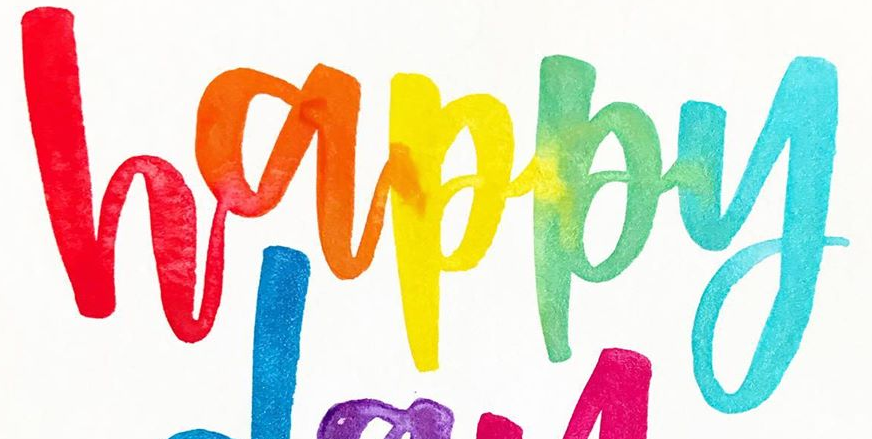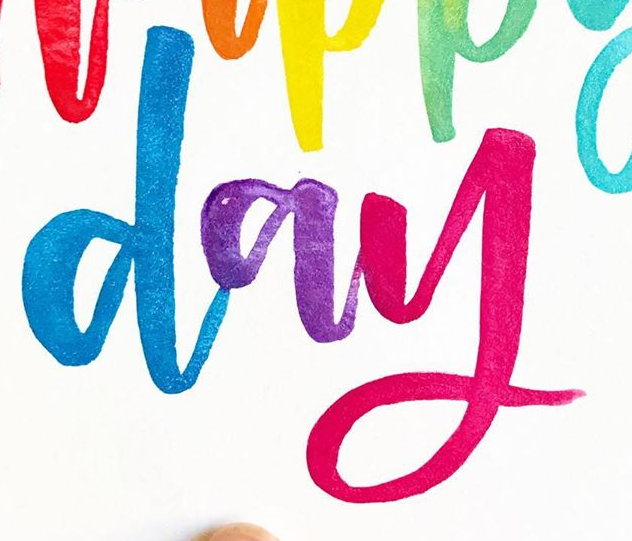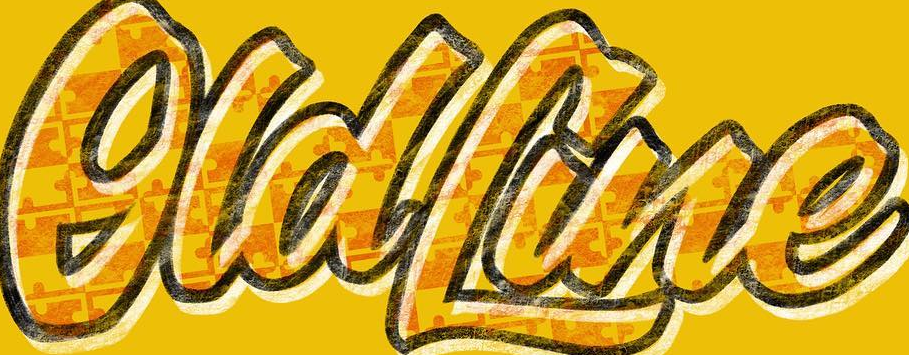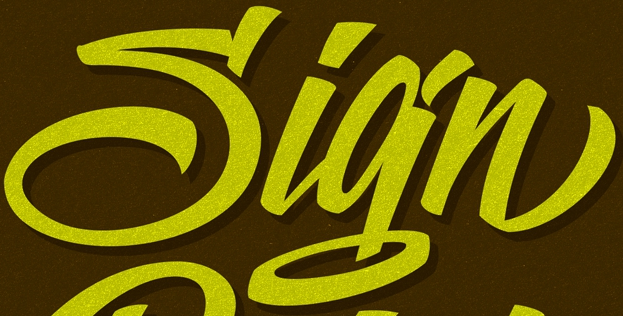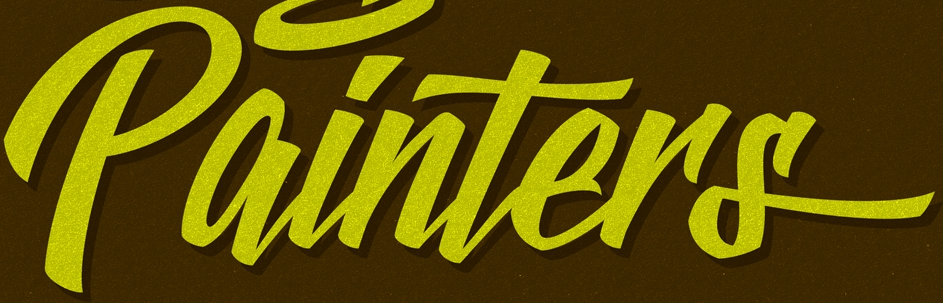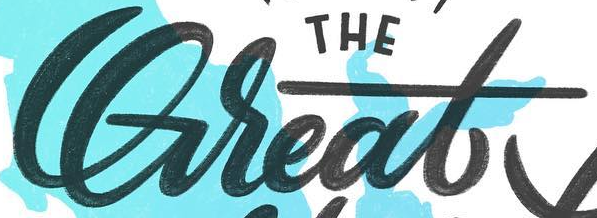Read the text from these images in sequence, separated by a semicolon. happy; day; OldLine; Sign; painTers; Great 